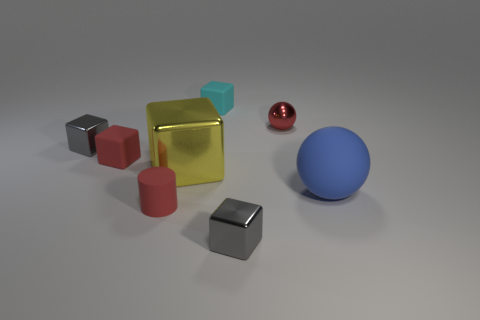Subtract all tiny red rubber cubes. How many cubes are left? 4 Subtract all yellow cubes. How many cubes are left? 4 Subtract 2 blocks. How many blocks are left? 3 Add 2 tiny blue objects. How many objects exist? 10 Subtract all yellow cubes. Subtract all cyan cylinders. How many cubes are left? 4 Subtract all balls. How many objects are left? 6 Add 3 large yellow blocks. How many large yellow blocks are left? 4 Add 2 cyan rubber blocks. How many cyan rubber blocks exist? 3 Subtract 1 red cylinders. How many objects are left? 7 Subtract all objects. Subtract all small yellow rubber objects. How many objects are left? 0 